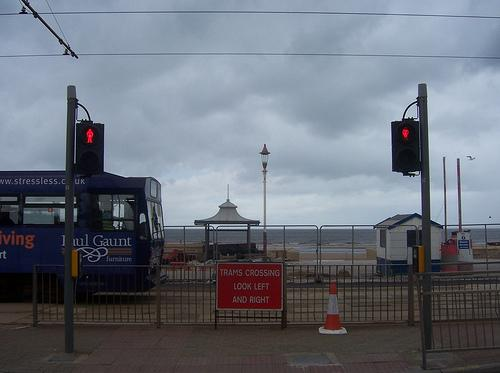Seeing dark clouds in the sky will remind you to bring what accessory that would be helpful if it starts to rain? Please explain your reasoning. umbrella. It looks cloudy and dark like it may rain. 